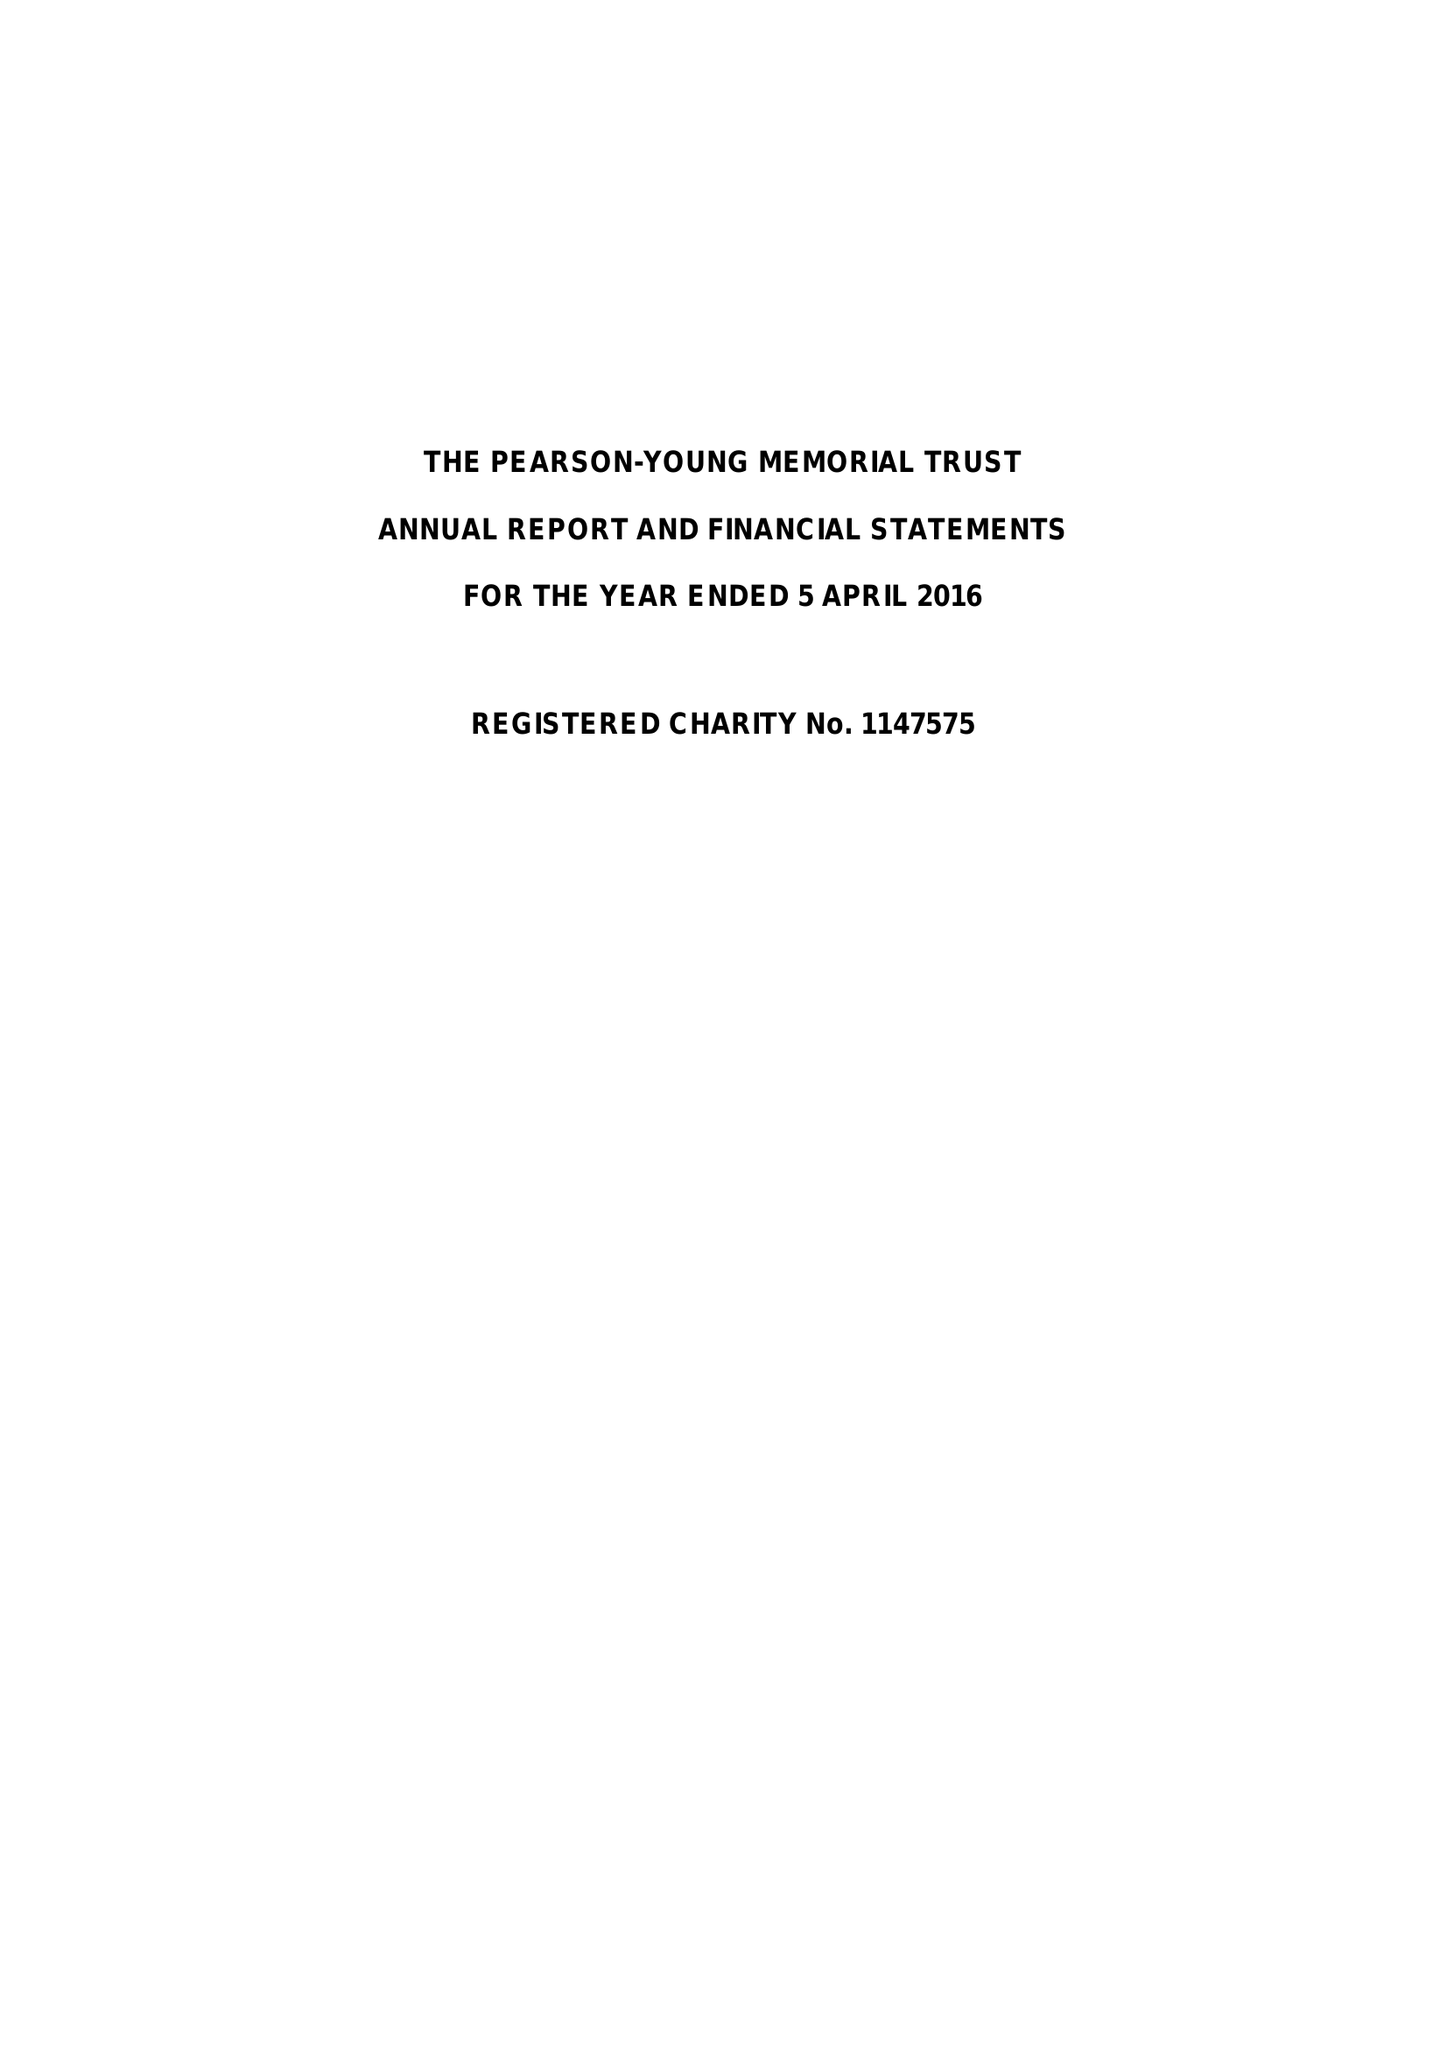What is the value for the income_annually_in_british_pounds?
Answer the question using a single word or phrase. 54869.77 